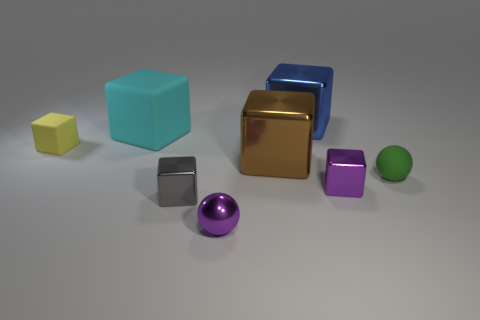How many tiny metal cubes are there?
Offer a terse response. 2. Are there more gray metallic blocks in front of the big cyan rubber cube than tiny red things?
Provide a succinct answer. Yes. There is a purple object on the right side of the small shiny ball; what is it made of?
Your response must be concise. Metal. What is the color of the tiny metal thing that is the same shape as the green rubber thing?
Offer a terse response. Purple. What number of small shiny things are the same color as the tiny rubber sphere?
Ensure brevity in your answer.  0. Does the ball in front of the tiny green rubber sphere have the same size as the rubber object in front of the tiny yellow matte object?
Offer a terse response. Yes. Is the size of the yellow rubber block the same as the ball in front of the gray cube?
Your answer should be compact. Yes. What size is the purple block?
Your response must be concise. Small. The tiny ball that is the same material as the gray thing is what color?
Offer a terse response. Purple. What number of small green objects are made of the same material as the big cyan thing?
Keep it short and to the point. 1. 